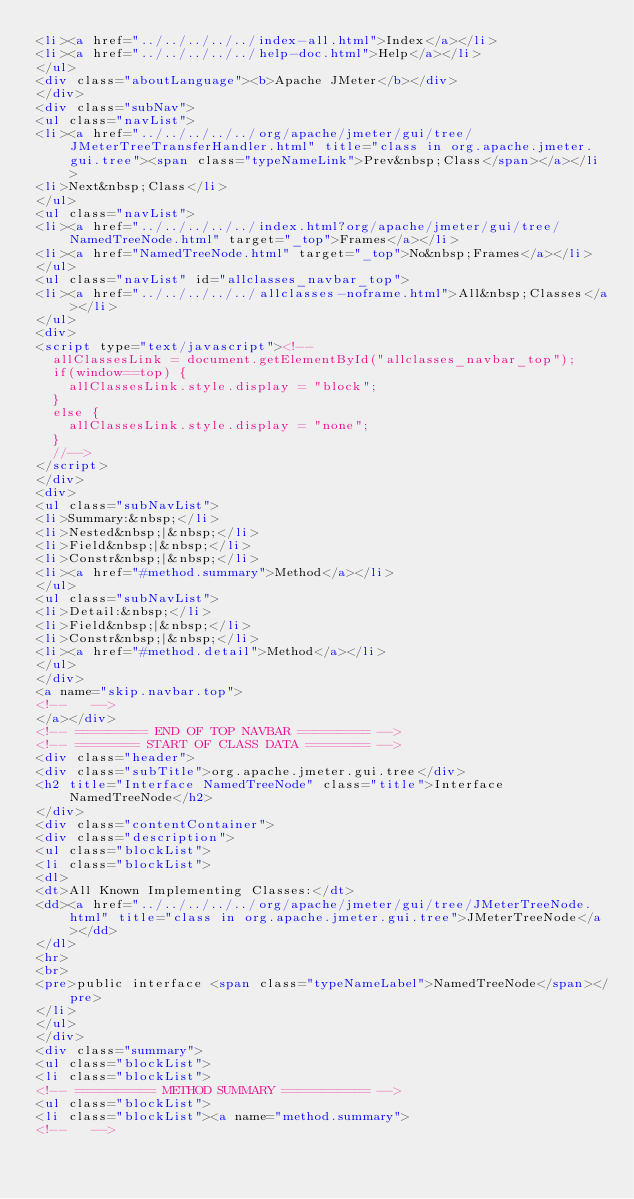<code> <loc_0><loc_0><loc_500><loc_500><_HTML_><li><a href="../../../../../index-all.html">Index</a></li>
<li><a href="../../../../../help-doc.html">Help</a></li>
</ul>
<div class="aboutLanguage"><b>Apache JMeter</b></div>
</div>
<div class="subNav">
<ul class="navList">
<li><a href="../../../../../org/apache/jmeter/gui/tree/JMeterTreeTransferHandler.html" title="class in org.apache.jmeter.gui.tree"><span class="typeNameLink">Prev&nbsp;Class</span></a></li>
<li>Next&nbsp;Class</li>
</ul>
<ul class="navList">
<li><a href="../../../../../index.html?org/apache/jmeter/gui/tree/NamedTreeNode.html" target="_top">Frames</a></li>
<li><a href="NamedTreeNode.html" target="_top">No&nbsp;Frames</a></li>
</ul>
<ul class="navList" id="allclasses_navbar_top">
<li><a href="../../../../../allclasses-noframe.html">All&nbsp;Classes</a></li>
</ul>
<div>
<script type="text/javascript"><!--
  allClassesLink = document.getElementById("allclasses_navbar_top");
  if(window==top) {
    allClassesLink.style.display = "block";
  }
  else {
    allClassesLink.style.display = "none";
  }
  //-->
</script>
</div>
<div>
<ul class="subNavList">
<li>Summary:&nbsp;</li>
<li>Nested&nbsp;|&nbsp;</li>
<li>Field&nbsp;|&nbsp;</li>
<li>Constr&nbsp;|&nbsp;</li>
<li><a href="#method.summary">Method</a></li>
</ul>
<ul class="subNavList">
<li>Detail:&nbsp;</li>
<li>Field&nbsp;|&nbsp;</li>
<li>Constr&nbsp;|&nbsp;</li>
<li><a href="#method.detail">Method</a></li>
</ul>
</div>
<a name="skip.navbar.top">
<!--   -->
</a></div>
<!-- ========= END OF TOP NAVBAR ========= -->
<!-- ======== START OF CLASS DATA ======== -->
<div class="header">
<div class="subTitle">org.apache.jmeter.gui.tree</div>
<h2 title="Interface NamedTreeNode" class="title">Interface NamedTreeNode</h2>
</div>
<div class="contentContainer">
<div class="description">
<ul class="blockList">
<li class="blockList">
<dl>
<dt>All Known Implementing Classes:</dt>
<dd><a href="../../../../../org/apache/jmeter/gui/tree/JMeterTreeNode.html" title="class in org.apache.jmeter.gui.tree">JMeterTreeNode</a></dd>
</dl>
<hr>
<br>
<pre>public interface <span class="typeNameLabel">NamedTreeNode</span></pre>
</li>
</ul>
</div>
<div class="summary">
<ul class="blockList">
<li class="blockList">
<!-- ========== METHOD SUMMARY =========== -->
<ul class="blockList">
<li class="blockList"><a name="method.summary">
<!--   --></code> 